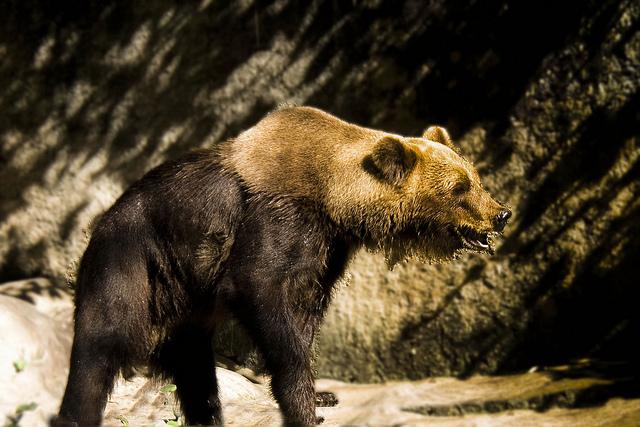What is the bear standing on?
Write a very short answer. Rock. This fox is wet or of two colors?
Give a very brief answer. Wet. Does this animal eat meat?
Write a very short answer. Yes. 